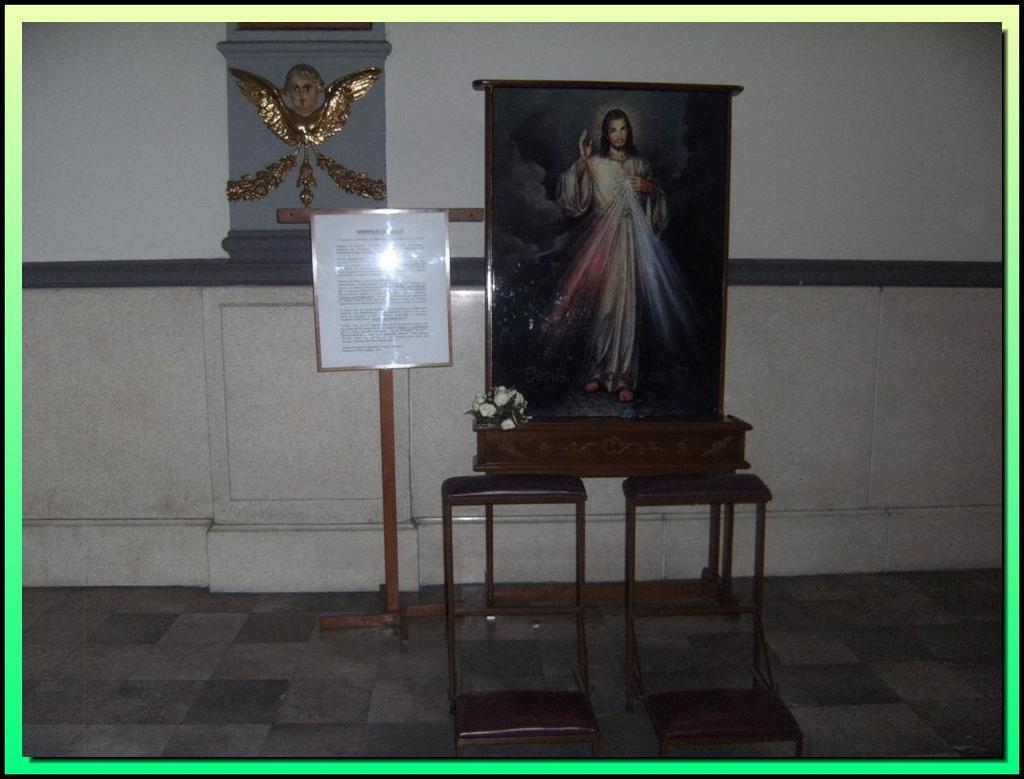What object in the image is typically used for displaying photos? There is a photo frame in the image. What object in the image is used for holding flowers? There is a flower vase in the image. What type of furniture can be seen in the image? There are tables in the image. What is the paper with text on a stand used for? The paper with text on a stand is likely used for displaying information or announcements. What type of decoration can be seen on the wall in the image? There is carving on the wall in the image. What type of authority figure is depicted in the image? There is no authority figure depicted in the image; it contains a photo frame, flower vase, tables, a paper with text on a stand, and carving on the wall. 